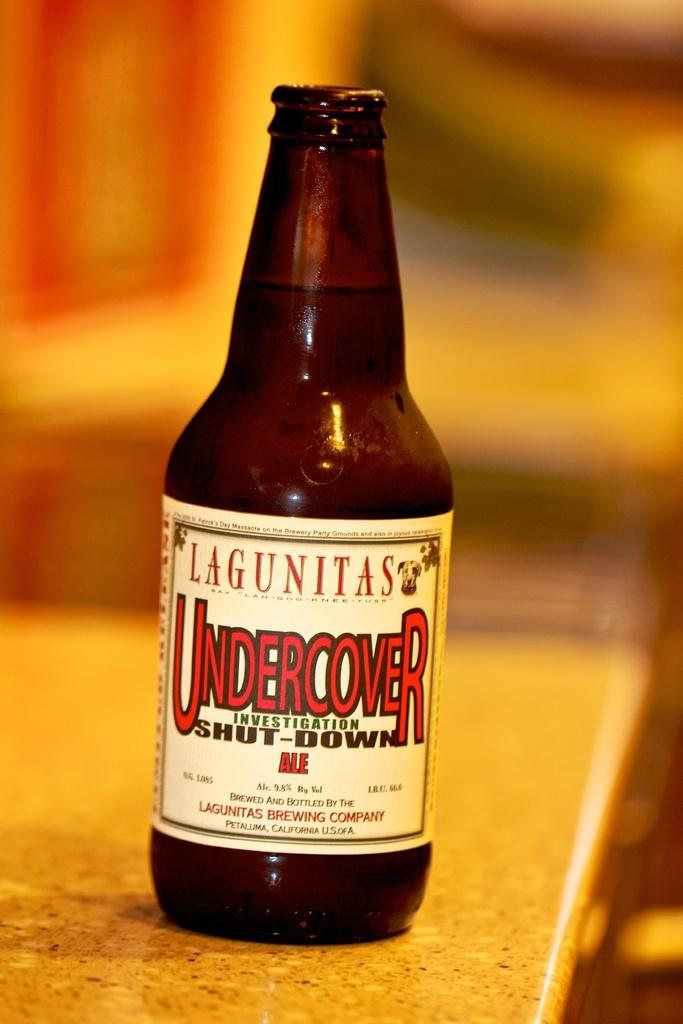<image>
Present a compact description of the photo's key features. An Undercover brand bottle is on a counter. 